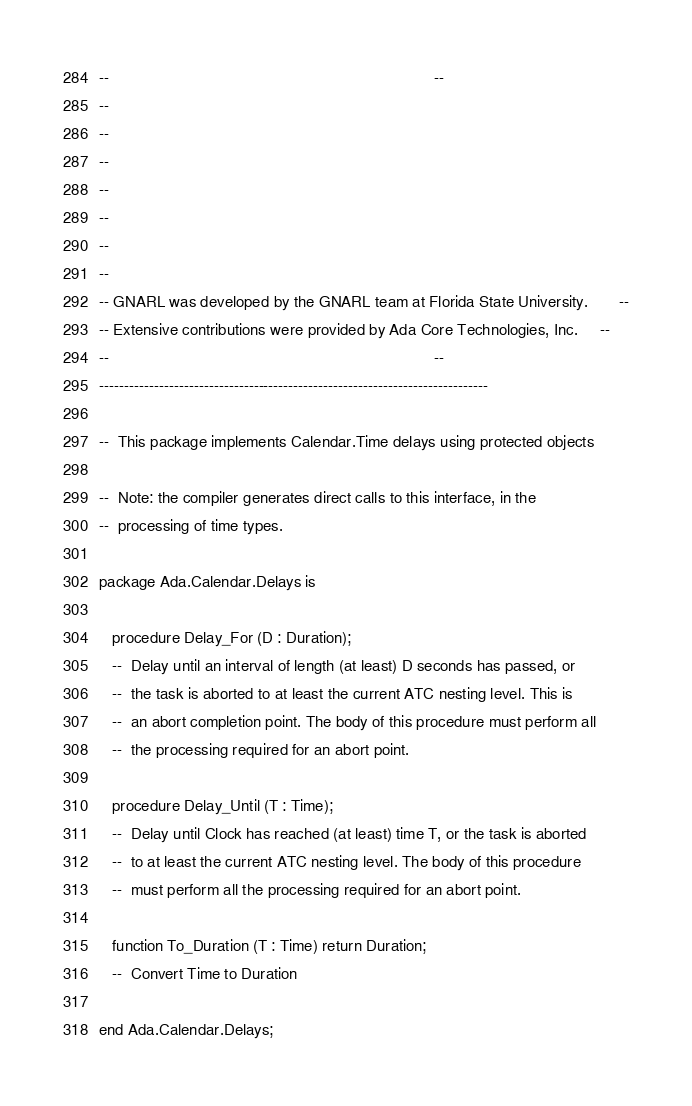<code> <loc_0><loc_0><loc_500><loc_500><_Ada_>--                                                                          --
--
--
--
--
--
--
--
-- GNARL was developed by the GNARL team at Florida State University.       --
-- Extensive contributions were provided by Ada Core Technologies, Inc.     --
--                                                                          --
------------------------------------------------------------------------------

--  This package implements Calendar.Time delays using protected objects

--  Note: the compiler generates direct calls to this interface, in the
--  processing of time types.

package Ada.Calendar.Delays is

   procedure Delay_For (D : Duration);
   --  Delay until an interval of length (at least) D seconds has passed, or
   --  the task is aborted to at least the current ATC nesting level. This is
   --  an abort completion point. The body of this procedure must perform all
   --  the processing required for an abort point.

   procedure Delay_Until (T : Time);
   --  Delay until Clock has reached (at least) time T, or the task is aborted
   --  to at least the current ATC nesting level. The body of this procedure
   --  must perform all the processing required for an abort point.

   function To_Duration (T : Time) return Duration;
   --  Convert Time to Duration

end Ada.Calendar.Delays;
</code> 